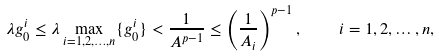<formula> <loc_0><loc_0><loc_500><loc_500>\lambda g _ { 0 } ^ { i } \leq \lambda \max _ { i = 1 , 2 , \dots , n } \{ g _ { 0 } ^ { i } \} < \frac { 1 } { A ^ { p - 1 } } \leq \left ( \frac { 1 } { A _ { i } } \right ) ^ { p - 1 } , \quad i = 1 , 2 , \dots , n ,</formula> 